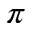<formula> <loc_0><loc_0><loc_500><loc_500>\pi</formula> 